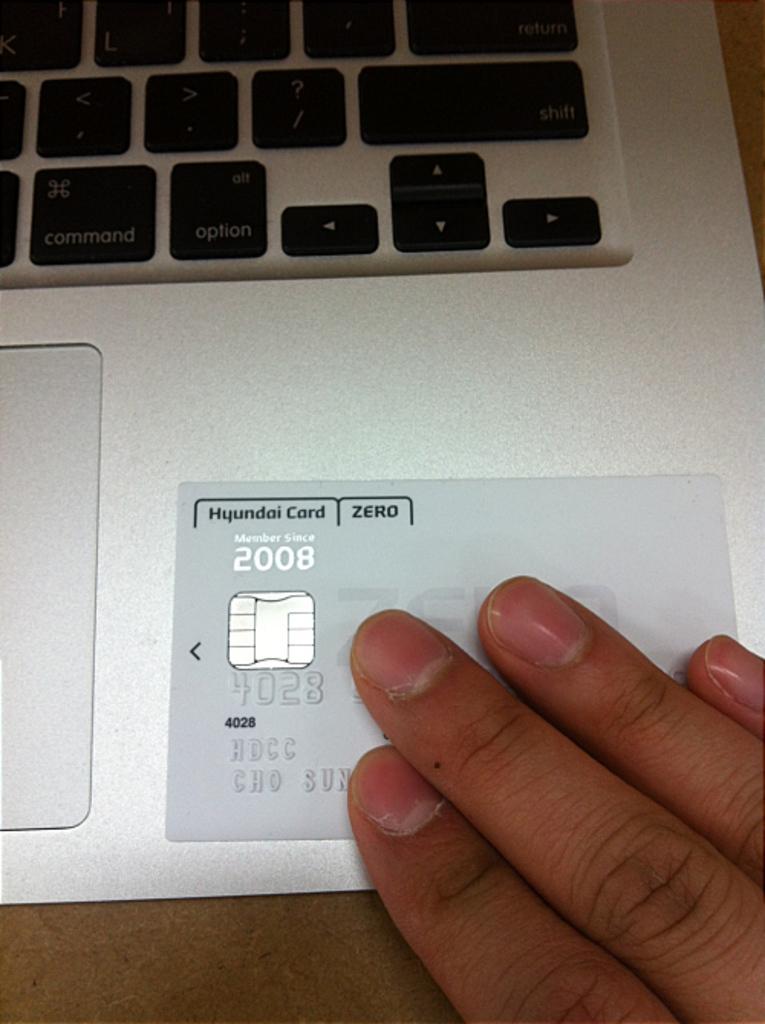When is this card from?
Give a very brief answer. 2008. 